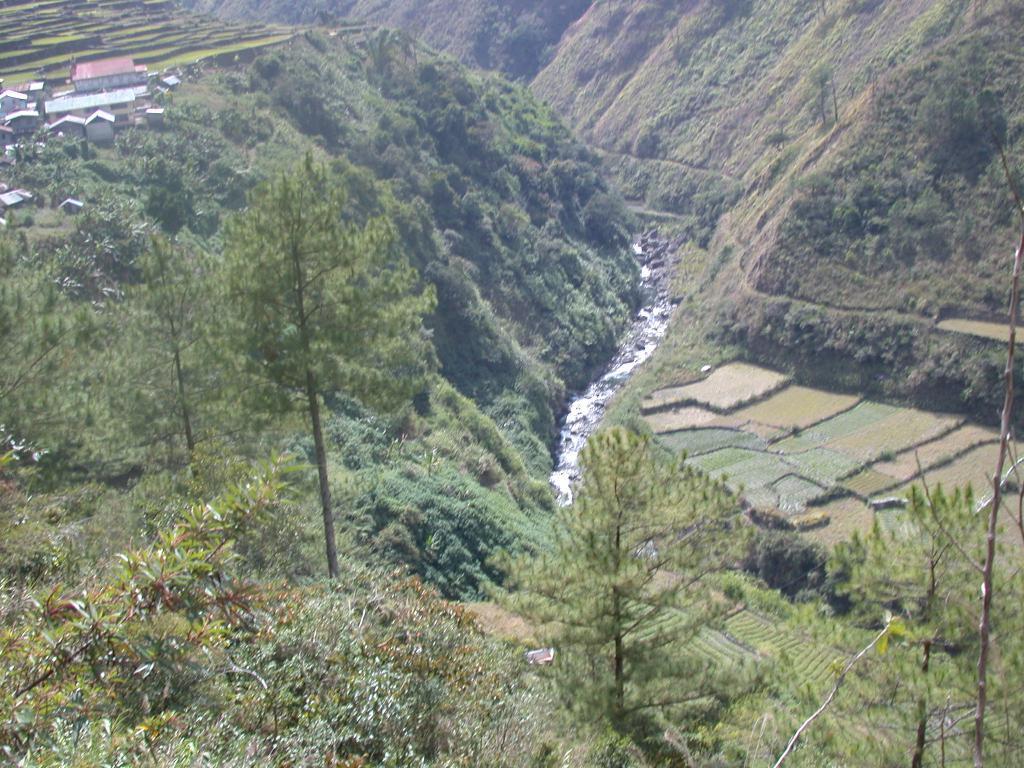Can you describe this image briefly? In this image there are hills in the middle. On the left side there are some houses above the hill. Beside the houses there are fields. On the left side bottom there are fields. In the middle there is water. At the bottom there are trees. 